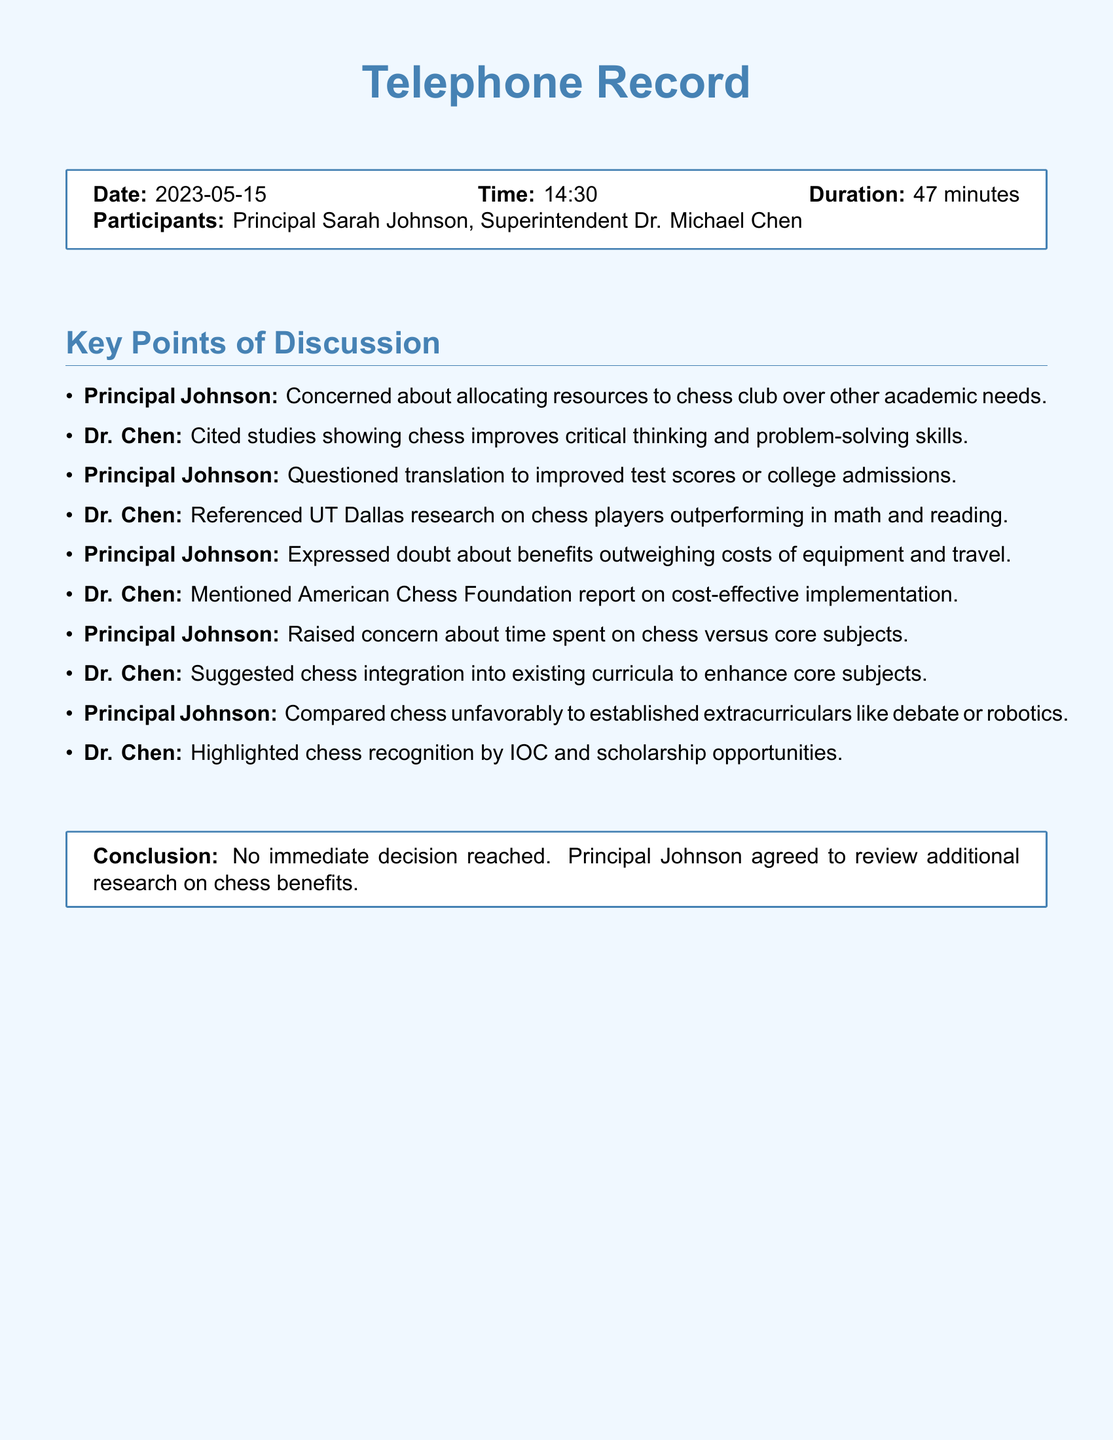What is the date of the call? The date of the call is mentioned in the document as the specific date it took place.
Answer: 2023-05-15 Who are the participants in the call? The document lists the names of the people involved in the conversation.
Answer: Principal Sarah Johnson, Superintendent Dr. Michael Chen What was the duration of the call? The duration of the call indicates how long the discussion lasted, as specified in the document.
Answer: 47 minutes What concern did Principal Johnson express about chess? The document states Principal Johnson's specific concern regarding chess and its impact on academic resources.
Answer: Allocating resources to chess club over other academic needs What research did Dr. Chen reference to support chess benefits? The document highlights a specific institution's research that Dr. Chen cited during the conversation about chess.
Answer: UT Dallas What did Principal Johnson compare chess unfavorably to? In the discussion, Principal Johnson made a comparison to other activities, which is noted in the document.
Answer: Established extracurriculars like debate or robotics What conclusion was reached by the end of the call? The document summarizes the final outcome of the conversation, including decisions made or not made.
Answer: No immediate decision reached How did Dr. Chen suggest integrating chess into education? Dr. Chen proposed a way for chess to be incorporated into existing structures, mentioned in the conversation.
Answer: Integration into existing curricula 